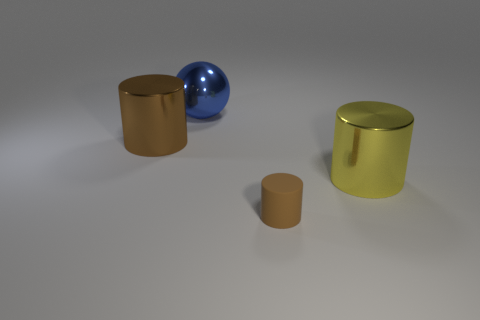Is the number of yellow metallic things less than the number of brown metallic cubes?
Your answer should be compact. No. There is a ball that is made of the same material as the big yellow cylinder; what is its size?
Give a very brief answer. Large. The blue shiny sphere has what size?
Keep it short and to the point. Large. What shape is the brown shiny object?
Your answer should be compact. Cylinder. Is the color of the cylinder left of the small matte cylinder the same as the small object?
Make the answer very short. Yes. The yellow shiny thing that is the same shape as the brown matte object is what size?
Provide a short and direct response. Large. Is there anything else that is made of the same material as the tiny brown object?
Provide a succinct answer. No. Is there a large shiny ball left of the big metallic cylinder to the right of the big cylinder on the left side of the large yellow metallic object?
Provide a succinct answer. Yes. What is the material of the brown object on the left side of the blue metal sphere?
Your answer should be very brief. Metal. What number of tiny objects are blue shiny objects or brown metal objects?
Ensure brevity in your answer.  0. 